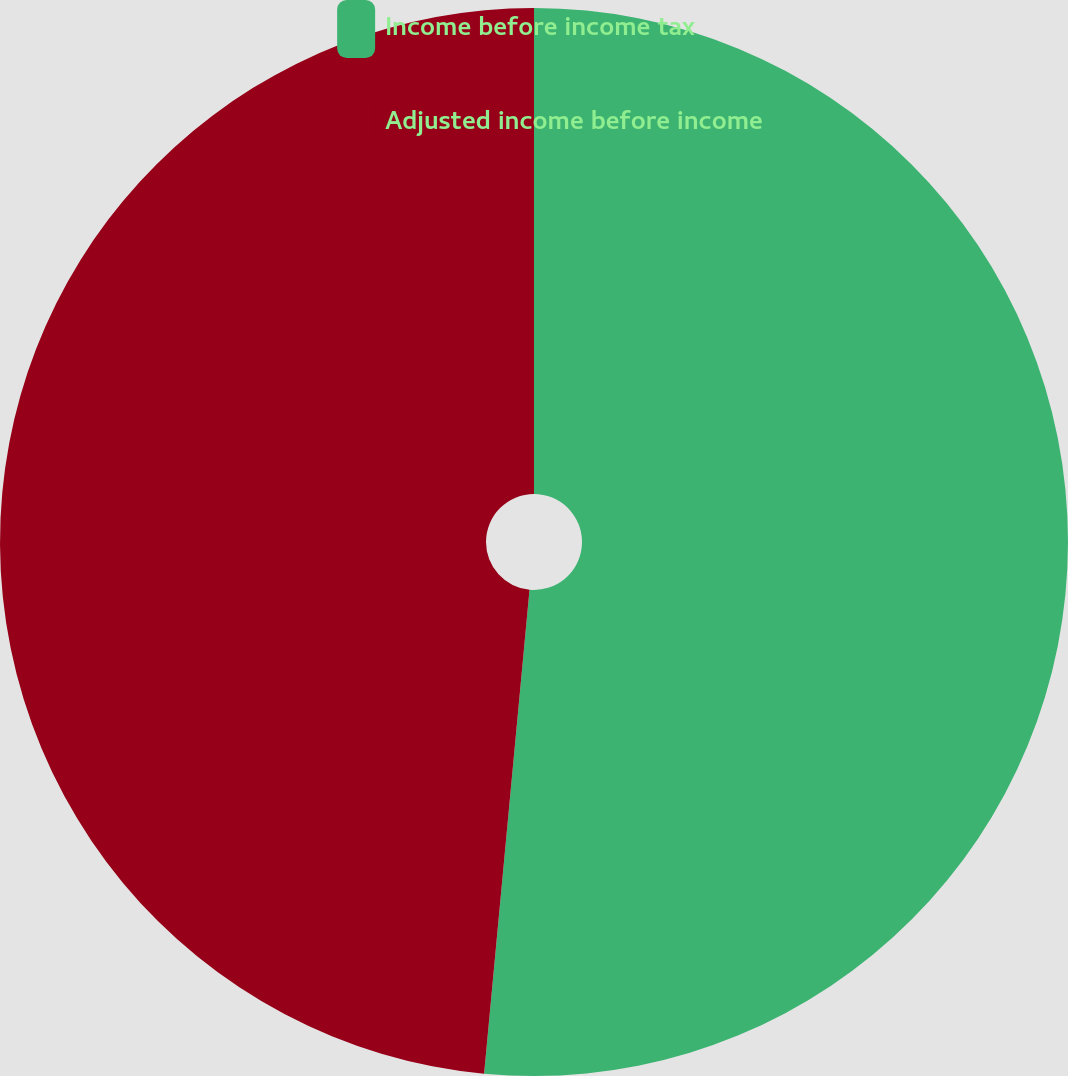Convert chart. <chart><loc_0><loc_0><loc_500><loc_500><pie_chart><fcel>Income before income tax<fcel>Adjusted income before income<nl><fcel>51.49%<fcel>48.51%<nl></chart> 